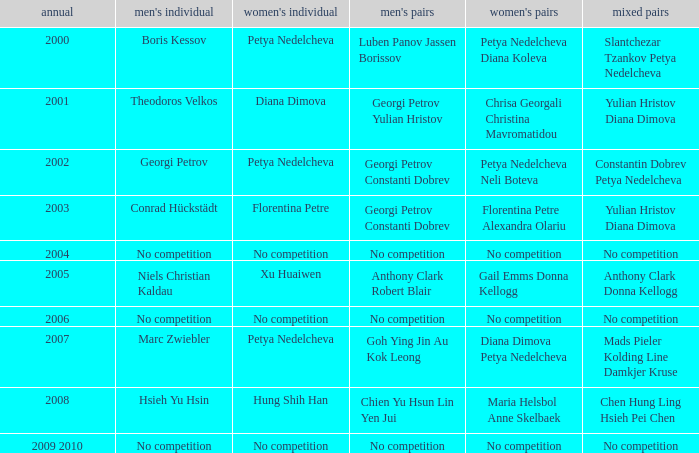In what year was there no competition for women? 2004, 2006, 2009 2010. 